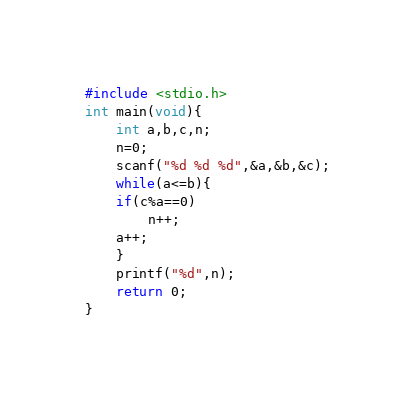<code> <loc_0><loc_0><loc_500><loc_500><_C_>#include <stdio.h>
int main(void){
    int a,b,c,n;
    n=0;
    scanf("%d %d %d",&a,&b,&c);
    while(a<=b){
	if(c%a==0)
		n++;
	a++;
    }
    printf("%d",n);
    return 0;
}</code> 